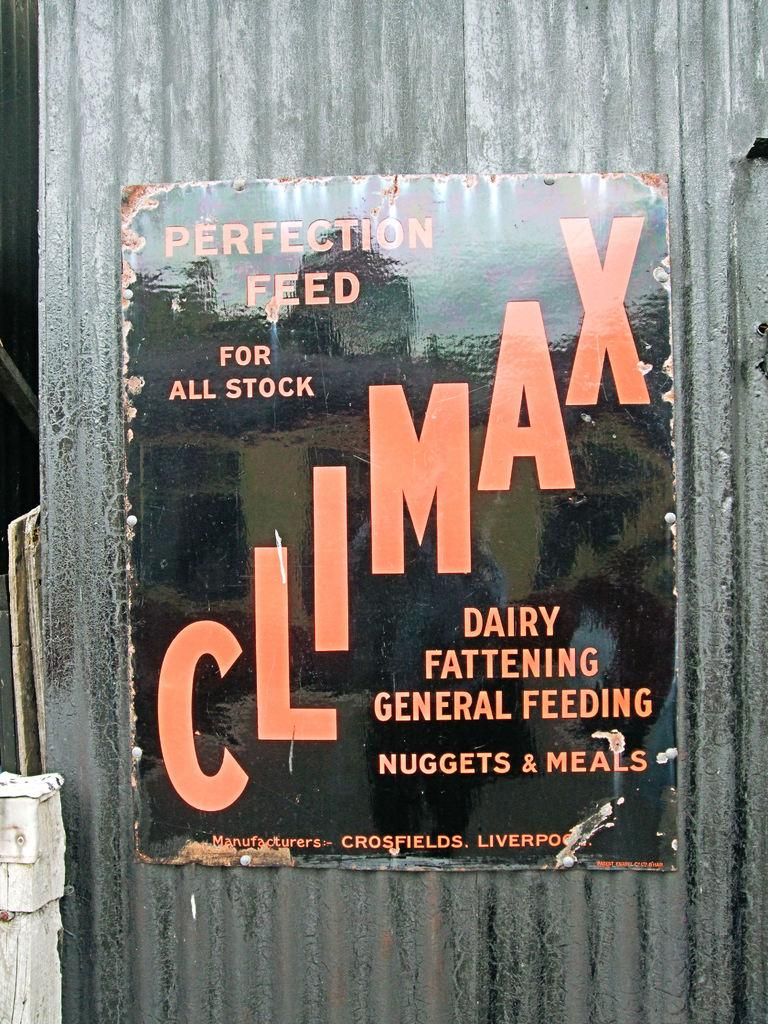<image>
Summarize the visual content of the image. A black and red sign proclaims Perfection feed for all livestock. 